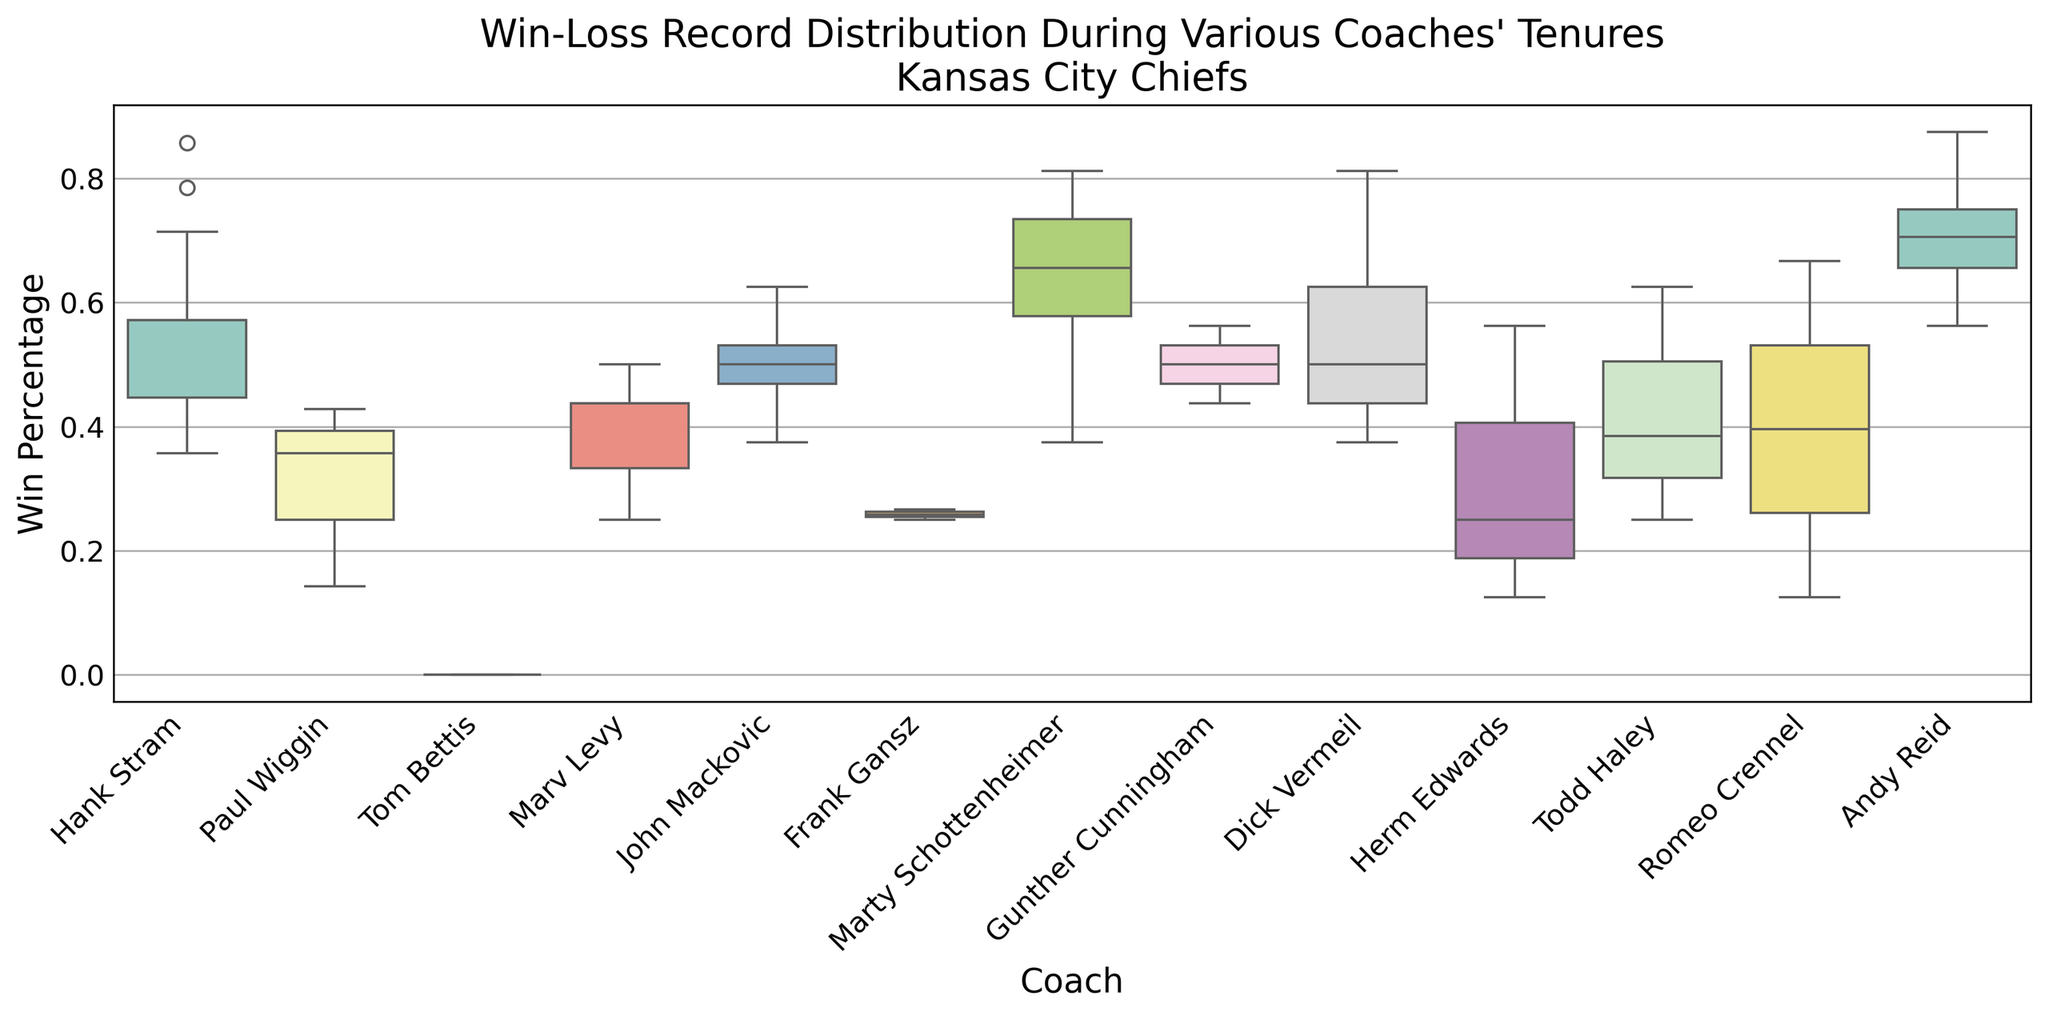Which coach has the highest median win percentage? By observing the boxplot, identify the coach whose median line within the box associated with their tenure is plotted the highest along the win percentage axis.
Answer: Andy Reid Which coach experienced the most variability in win percentages? Assess the range between the whiskers (the minimum and maximum points) for each coach shown in the boxplot. The coach with the greatest distance between them has the most variability.
Answer: Marv Levy What is the approximate median win percentage during Hank Stram's tenure? Locate the median line within the box associated with Hank Stram's tenure on the plot, and approximate its value by comparing it to the y-axis labeling.
Answer: Around 0.571 Which coach has a lower median win percentage, Hank Stram or Marty Schottenheimer? Compare the median lines within the boxes of Hank Stram and Marty Schottenheimer. The one positioned lower on the y-axis has a lower median win percentage.
Answer: Hank Stram Among Marv Levy, John Mackovic, and Dick Vermeil, who has the highest median win percentage? Compare the median lines within the boxes of Marv Levy, John Mackovic, and Dick Vermeil. The highest median win percentage corresponds to the median line furthest up the y-axis.
Answer: Dick Vermeil Which coach's tenure results in a win percentage distribution with the least inconsistency? Look for the box in the plot with the smallest interquartile range (IQR), shown as the distance from the bottom to the top of the box for each coach. This would indicate the least inconsistency.
Answer: Andy Reid Is there any coach whose win percentage median is below 0.5? Observe the position of the median lines within each box and identify any that fall below the 0.5 mark on the y-axis. Several coaches may have this characteristic.
Answer: Yes, several coaches including Todd Haley and Romeo Crennel Who has a wider range of win percentages, Todd Haley or Gunther Cunningham? Compare the ranges between the whiskers (from minimum to maximum) of Todd Haley and Gunther Cunningham on the plot. The wider range signals higher variability.
Answer: Todd Haley Does Frank Gansz or Herm Edwards have a more symmetric win percentage distribution? Examine the shape of the boxes and whiskers for Frank Gansz and Herm Edwards. A more symmetric distribution will have the median line closer to the center of the box and whiskers at more even distances from the box.
Answer: Herm Edwards 